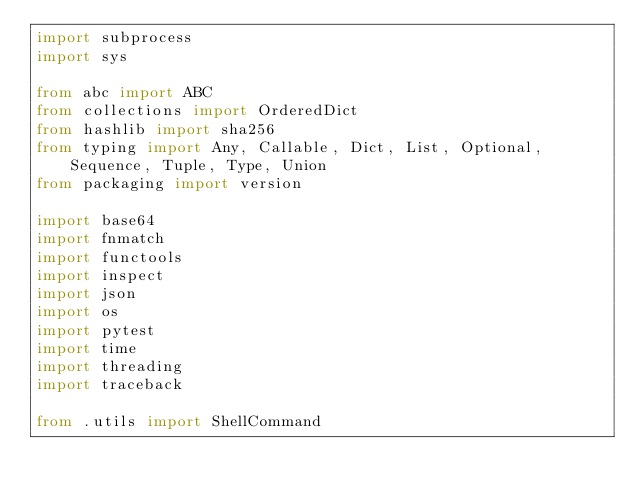<code> <loc_0><loc_0><loc_500><loc_500><_Python_>import subprocess
import sys

from abc import ABC
from collections import OrderedDict
from hashlib import sha256
from typing import Any, Callable, Dict, List, Optional, Sequence, Tuple, Type, Union
from packaging import version

import base64
import fnmatch
import functools
import inspect
import json
import os
import pytest
import time
import threading
import traceback

from .utils import ShellCommand
</code> 